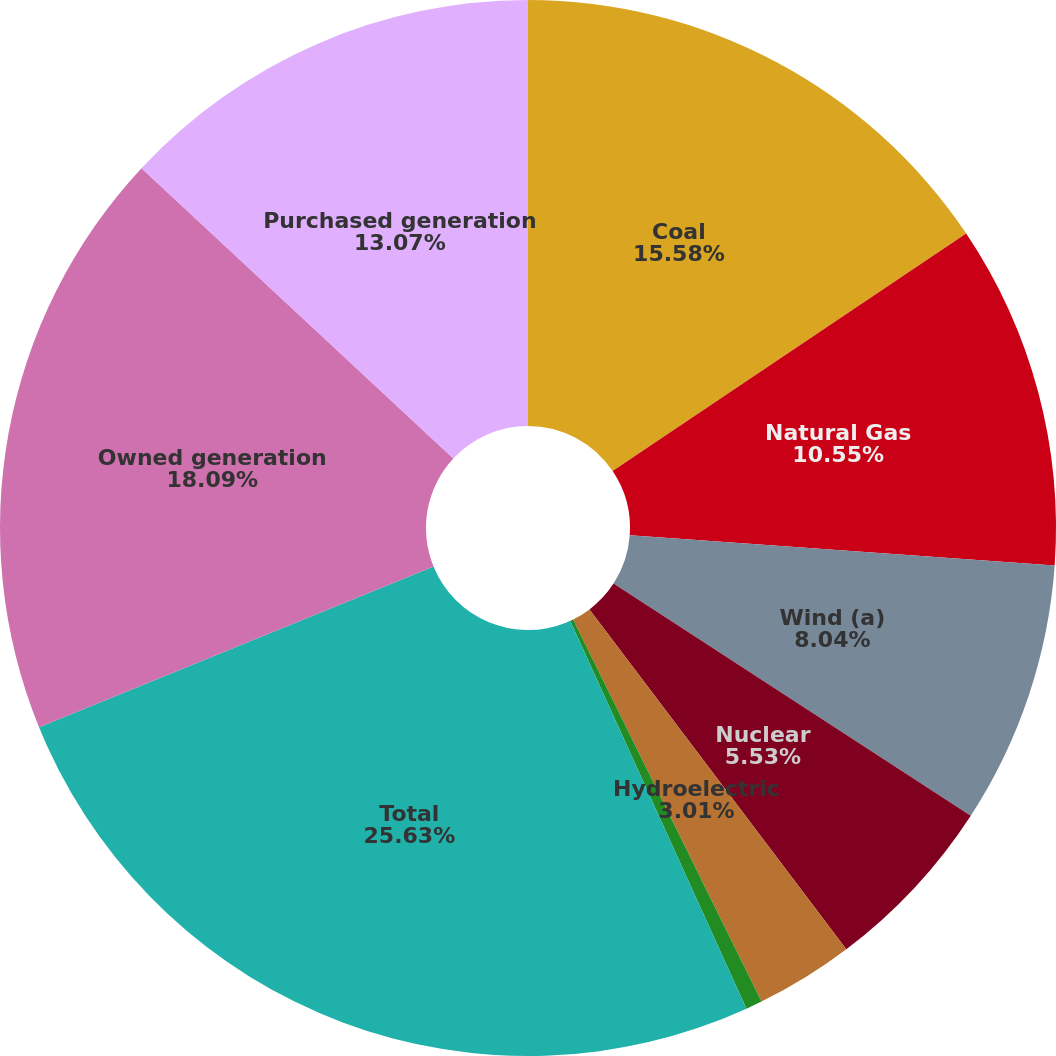<chart> <loc_0><loc_0><loc_500><loc_500><pie_chart><fcel>Coal<fcel>Natural Gas<fcel>Wind (a)<fcel>Nuclear<fcel>Hydroelectric<fcel>Other (b)<fcel>Total<fcel>Owned generation<fcel>Purchased generation<nl><fcel>15.58%<fcel>10.55%<fcel>8.04%<fcel>5.53%<fcel>3.01%<fcel>0.5%<fcel>25.63%<fcel>18.09%<fcel>13.07%<nl></chart> 